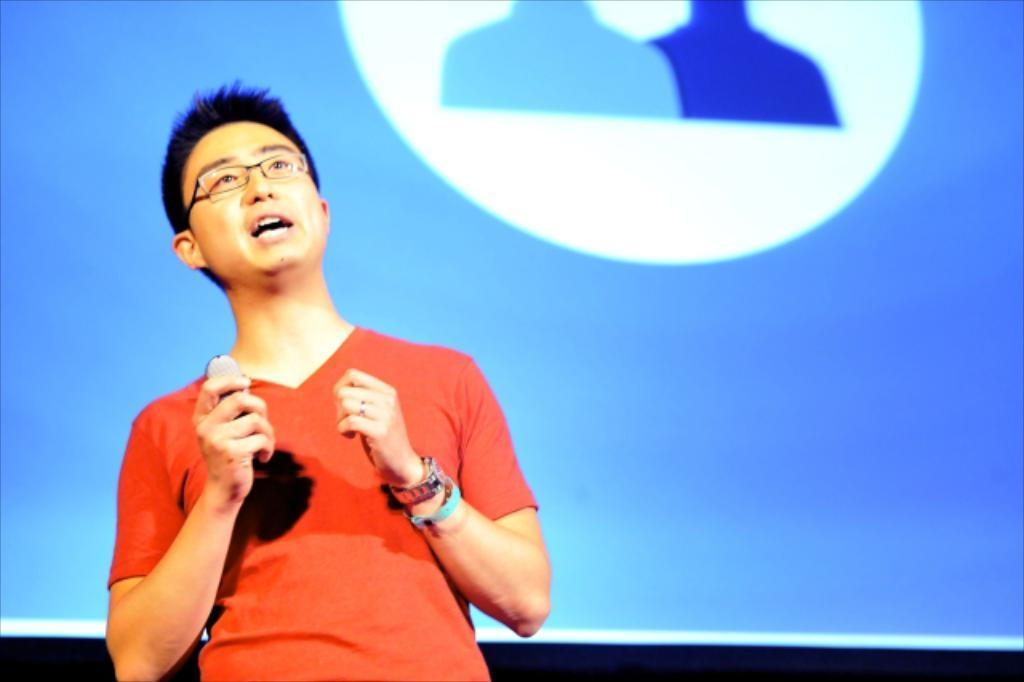What is the main subject of the image? There is a person standing in the image. Can you describe the background of the image? There is a screen visible in the background of the image. What type of orange instrument is being played by the person in the image? There is no orange instrument present in the image, and the person is not playing any instrument. 